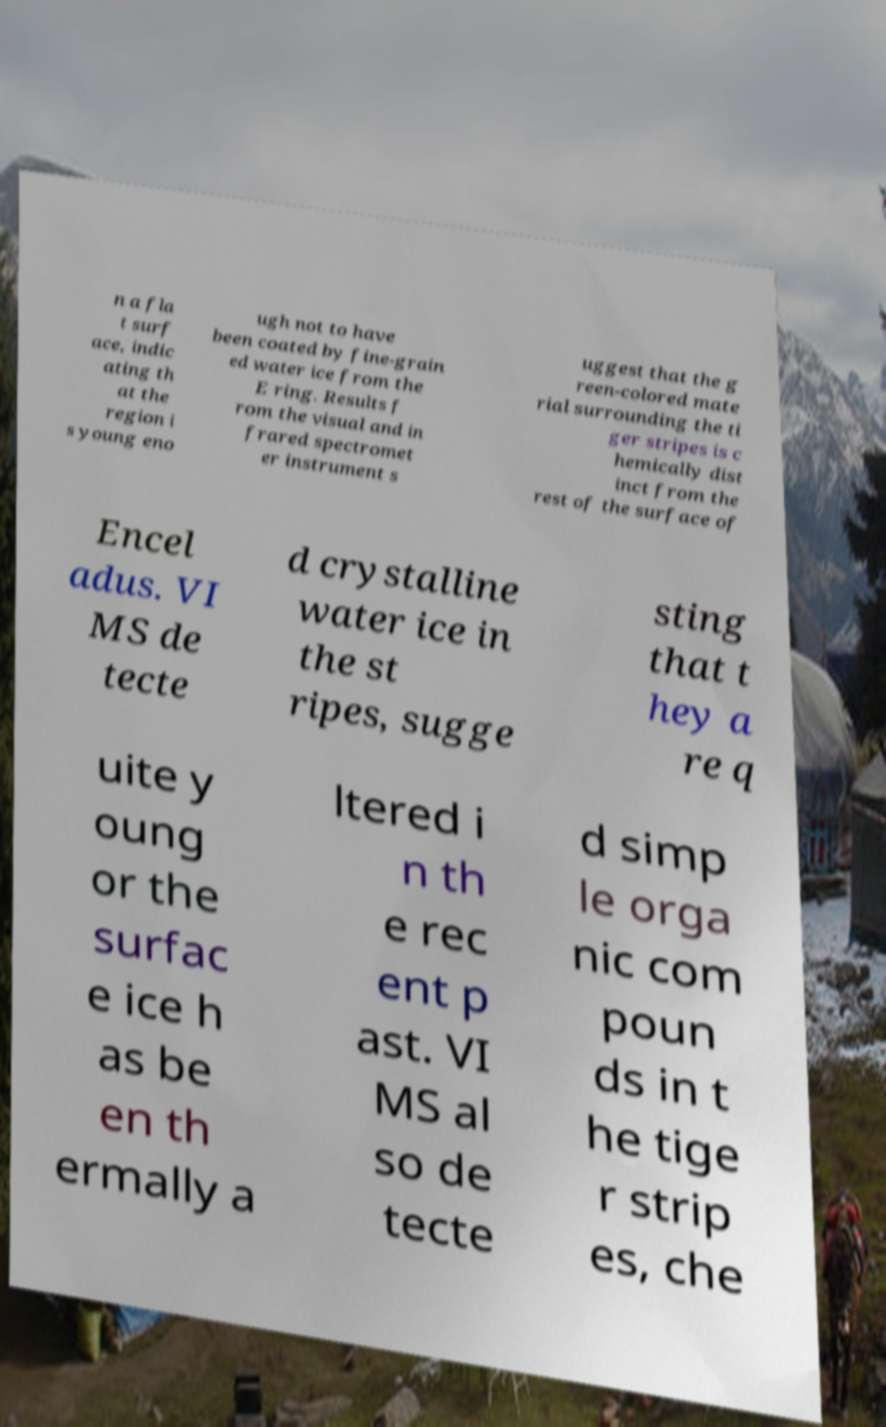For documentation purposes, I need the text within this image transcribed. Could you provide that? n a fla t surf ace, indic ating th at the region i s young eno ugh not to have been coated by fine-grain ed water ice from the E ring. Results f rom the visual and in frared spectromet er instrument s uggest that the g reen-colored mate rial surrounding the ti ger stripes is c hemically dist inct from the rest of the surface of Encel adus. VI MS de tecte d crystalline water ice in the st ripes, sugge sting that t hey a re q uite y oung or the surfac e ice h as be en th ermally a ltered i n th e rec ent p ast. VI MS al so de tecte d simp le orga nic com poun ds in t he tige r strip es, che 